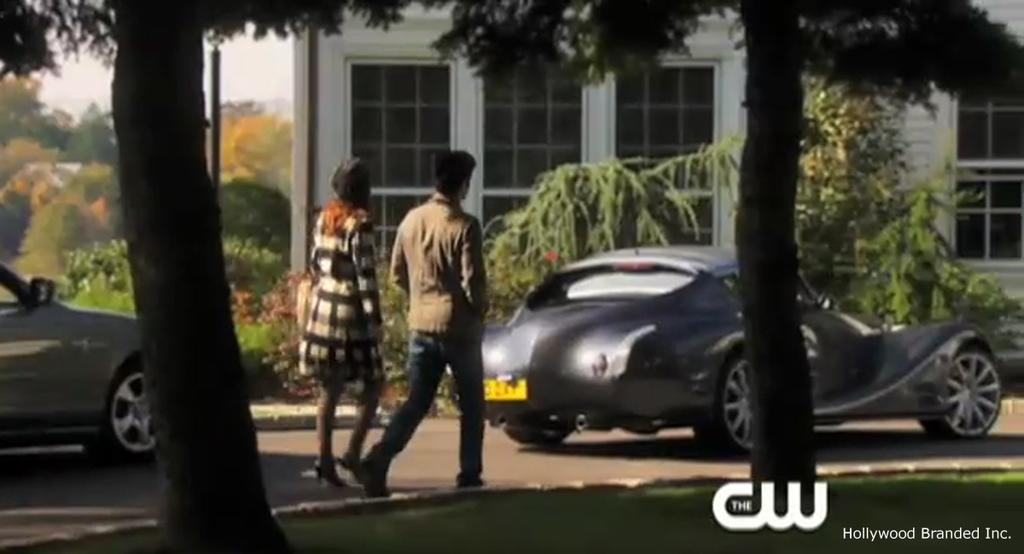How many people are standing on the road in the image? There are two persons standing on the road in the image. What else can be seen on the road in the background? There are two cars parked on the road in the background. What type of natural scenery is visible in the background? There is a group of trees in the background. What type of man-made structures are visible in the background? There is a building and a pole in the background. What is visible in the sky in the background? The sky is visible in the background. What type of servant can be seen attending to the persons in the image? There is no servant present in the image; it only shows two persons standing on the road. What type of stone is visible in the image? There is no stone visible in the image. 